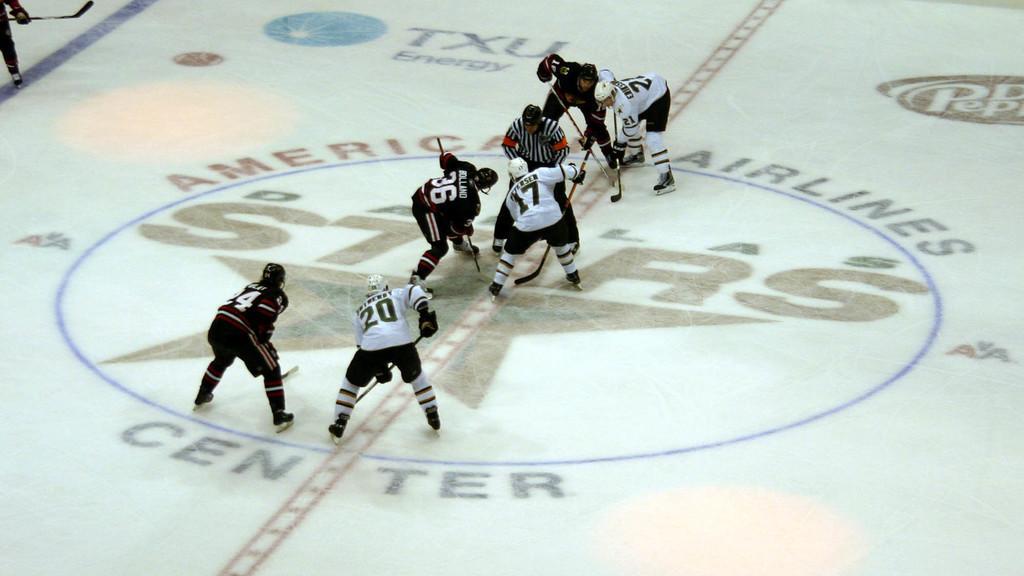Can you describe this image briefly? This image consists of many persons playing hockey. At the bottom, there is a ground. They are wearing helmets, jerseys and holding hockey sticks. 